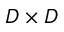Convert formula to latex. <formula><loc_0><loc_0><loc_500><loc_500>D \times D</formula> 